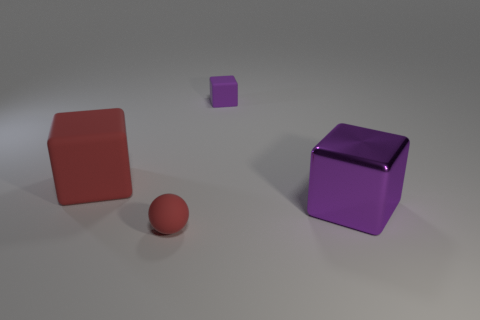The big matte object is what color?
Provide a succinct answer. Red. What number of objects are either cyan blocks or red rubber blocks?
Your response must be concise. 1. Is there another object of the same shape as the large matte object?
Provide a short and direct response. Yes. Is the color of the large thing that is right of the red rubber cube the same as the tiny block?
Make the answer very short. Yes. There is a large rubber object in front of the purple block that is behind the big red rubber thing; what is its shape?
Your answer should be very brief. Cube. Are there any matte objects that have the same size as the purple metal thing?
Provide a succinct answer. Yes. Are there fewer small spheres than blocks?
Your response must be concise. Yes. The small matte thing in front of the big thing that is behind the large block that is on the right side of the tiny red matte object is what shape?
Keep it short and to the point. Sphere. What number of things are purple blocks behind the purple metal cube or red things in front of the purple shiny thing?
Keep it short and to the point. 2. There is a purple matte cube; are there any things on the right side of it?
Give a very brief answer. Yes. 